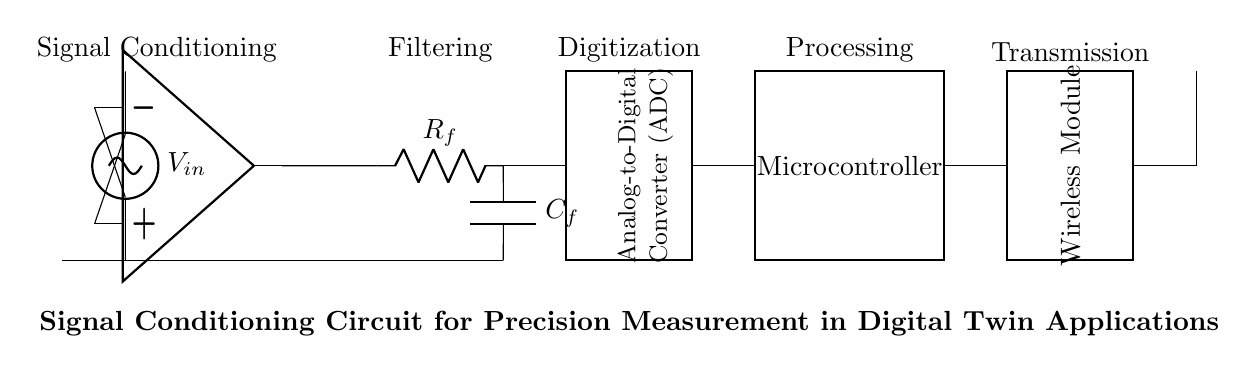What is the input voltage in the circuit? The input voltage, labeled as V_in in the circuit diagram, is provided through a voltage source indicated at the top left corner.
Answer: V_in What type of amplifier is used in this circuit? The circuit diagram features an instrumentation amplifier, which is recognized by its specific symbol for operational amplifiers typically used for signal conditioning.
Answer: Instrumentation amplifier What is the purpose of the low-pass filter? The low-pass filter, which consists of a resistor and a capacitor (R_f and C_f), is used in the circuit to remove high-frequency noise from the signal to improve measurement precision.
Answer: To filter high-frequency noise What components are involved in the digitization process? The circuit includes an Analog-to-Digital Converter (ADC), which is a rectangular block in the diagram, and is essential for converting the conditioned analog signal into a digital format.
Answer: ADC How is the processed signal transmitted in the circuit? The processed signal is transmitted wirelessly through a wireless module depicted as a rectangle in the circuit, following the microcontroller stage.
Answer: Wireless module What is the main function of the microcontroller in this circuit? The microcontroller processes the digitized signal from the ADC and controls the overall operation of the circuit, enabling further data manipulation and transmission.
Answer: Processing Which component provides signal amplification before filtering? The instrumentation amplifier amplifies the input signal before it proceeds to the low-pass filter stage, allowing for better accuracy in measurements by increasing the signal amplitude.
Answer: Instrumentation amplifier 